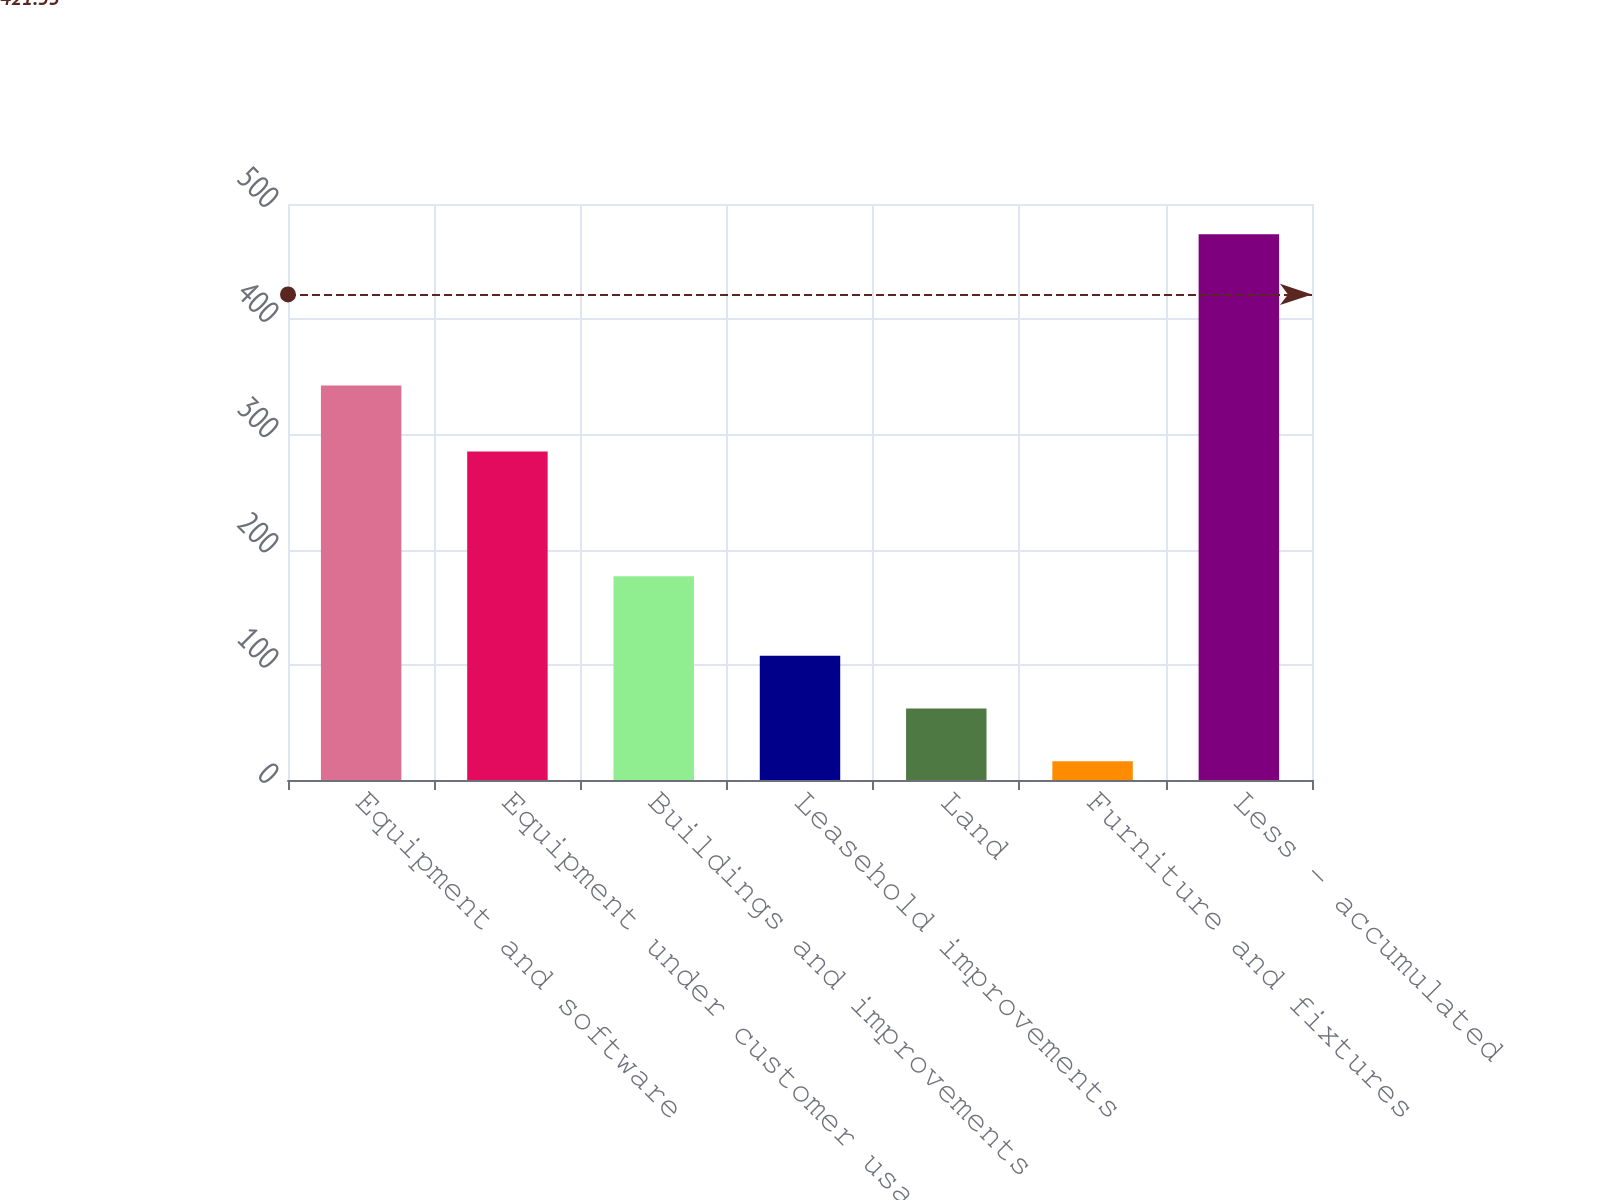Convert chart. <chart><loc_0><loc_0><loc_500><loc_500><bar_chart><fcel>Equipment and software<fcel>Equipment under customer usage<fcel>Buildings and improvements<fcel>Leasehold improvements<fcel>Land<fcel>Furniture and fixtures<fcel>Less - accumulated<nl><fcel>342.5<fcel>285.2<fcel>176.9<fcel>107.8<fcel>62.05<fcel>16.3<fcel>473.8<nl></chart> 